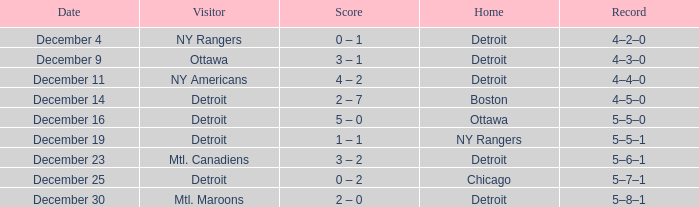What score has detroit as the home, and December 9 as the date? 3 – 1. 